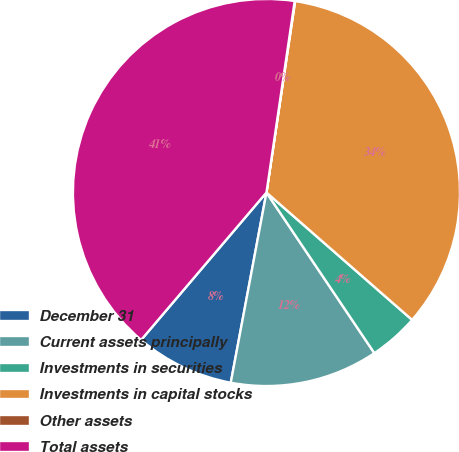Convert chart. <chart><loc_0><loc_0><loc_500><loc_500><pie_chart><fcel>December 31<fcel>Current assets principally<fcel>Investments in securities<fcel>Investments in capital stocks<fcel>Other assets<fcel>Total assets<nl><fcel>8.26%<fcel>12.37%<fcel>4.15%<fcel>34.07%<fcel>0.04%<fcel>41.12%<nl></chart> 